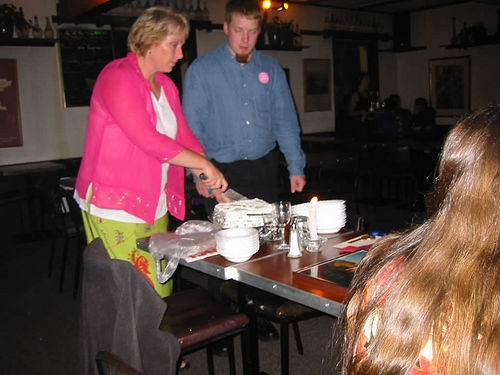Describe the objects in this image and their specific colors. I can see people in black, gray, tan, and brown tones, people in black, salmon, brown, and lightgray tones, people in black, gray, and brown tones, chair in black and gray tones, and chair in black, maroon, and brown tones in this image. 